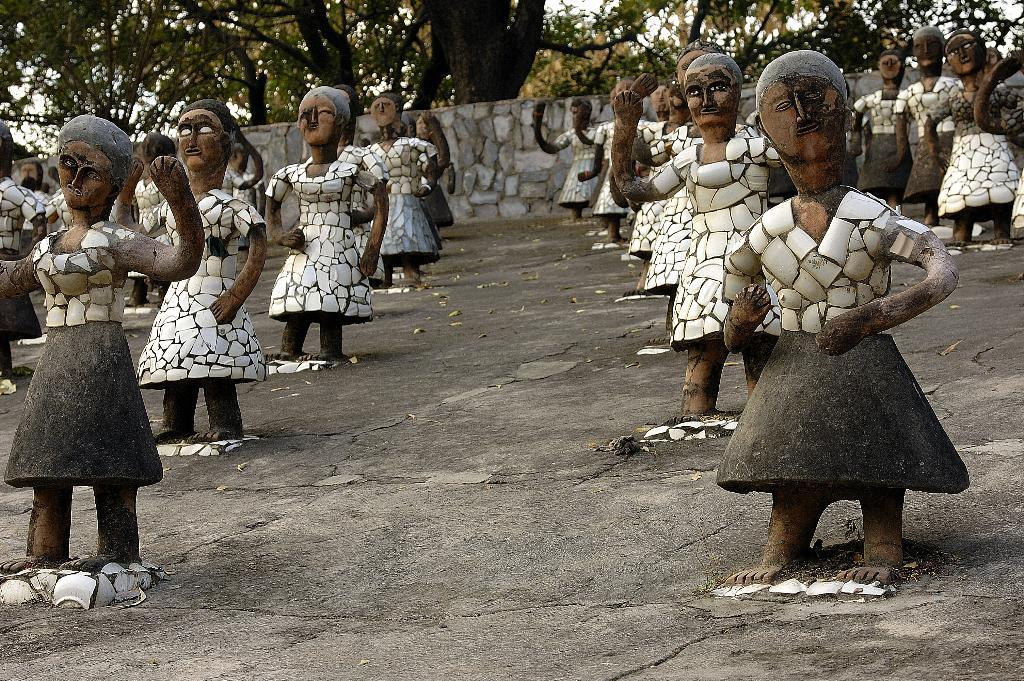What type of objects can be seen in the image? There are statues in the image. What is visible in the background of the image? There is a wall, trees, and the sky visible in the background of the image. What type of thread is being used by the statues to write their names in the image? There is no thread or writing present in the image; the statues are not depicted as writing anything. 